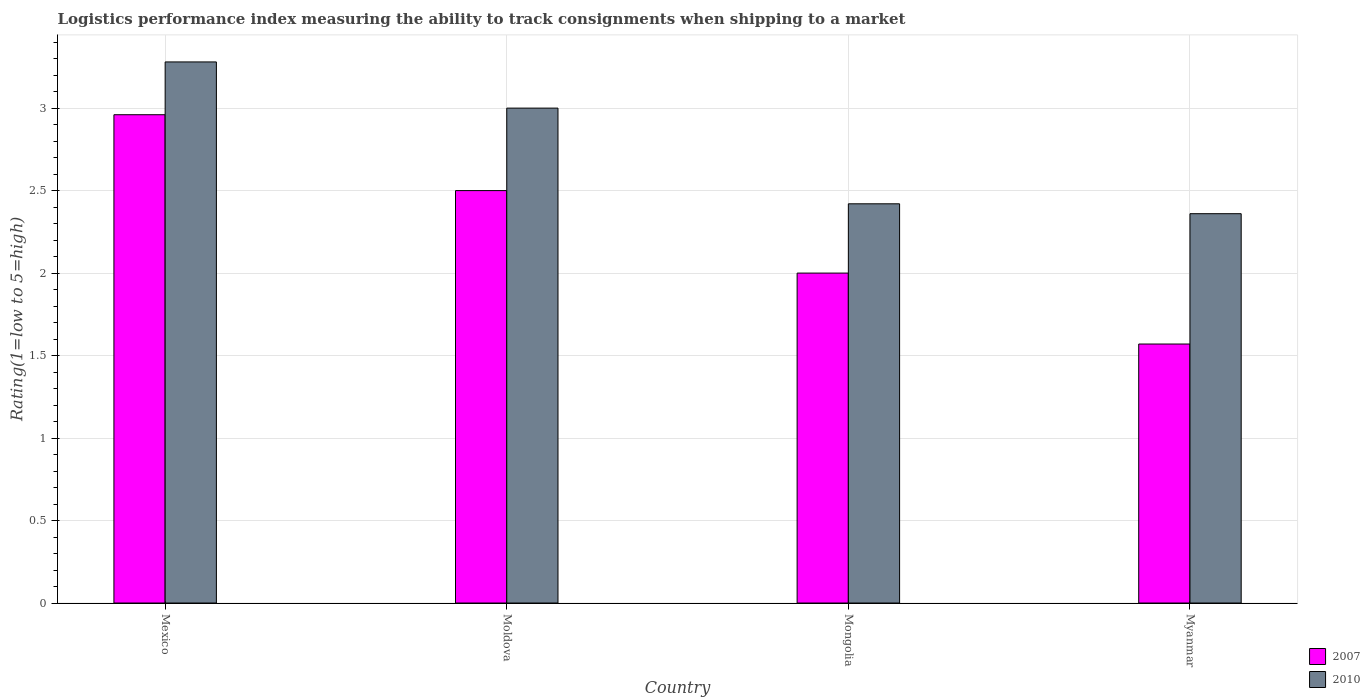How many different coloured bars are there?
Ensure brevity in your answer.  2. Are the number of bars per tick equal to the number of legend labels?
Provide a succinct answer. Yes. What is the label of the 4th group of bars from the left?
Your response must be concise. Myanmar. What is the Logistic performance index in 2007 in Mexico?
Offer a terse response. 2.96. Across all countries, what is the maximum Logistic performance index in 2007?
Make the answer very short. 2.96. Across all countries, what is the minimum Logistic performance index in 2007?
Keep it short and to the point. 1.57. In which country was the Logistic performance index in 2007 minimum?
Your answer should be compact. Myanmar. What is the total Logistic performance index in 2007 in the graph?
Provide a short and direct response. 9.03. What is the difference between the Logistic performance index in 2010 in Mexico and that in Mongolia?
Offer a terse response. 0.86. What is the difference between the Logistic performance index in 2007 in Mongolia and the Logistic performance index in 2010 in Mexico?
Your answer should be very brief. -1.28. What is the average Logistic performance index in 2007 per country?
Provide a succinct answer. 2.26. What is the difference between the Logistic performance index of/in 2010 and Logistic performance index of/in 2007 in Mongolia?
Offer a terse response. 0.42. In how many countries, is the Logistic performance index in 2010 greater than 0.1?
Your response must be concise. 4. What is the ratio of the Logistic performance index in 2010 in Mongolia to that in Myanmar?
Provide a succinct answer. 1.03. What is the difference between the highest and the second highest Logistic performance index in 2010?
Give a very brief answer. 0.58. What is the difference between the highest and the lowest Logistic performance index in 2007?
Offer a terse response. 1.39. What does the 2nd bar from the left in Moldova represents?
Your response must be concise. 2010. What does the 1st bar from the right in Mexico represents?
Offer a terse response. 2010. How many bars are there?
Keep it short and to the point. 8. Are the values on the major ticks of Y-axis written in scientific E-notation?
Provide a succinct answer. No. Does the graph contain any zero values?
Your answer should be compact. No. Does the graph contain grids?
Provide a succinct answer. Yes. How many legend labels are there?
Offer a very short reply. 2. How are the legend labels stacked?
Offer a very short reply. Vertical. What is the title of the graph?
Offer a terse response. Logistics performance index measuring the ability to track consignments when shipping to a market. Does "2015" appear as one of the legend labels in the graph?
Your response must be concise. No. What is the label or title of the Y-axis?
Your answer should be compact. Rating(1=low to 5=high). What is the Rating(1=low to 5=high) of 2007 in Mexico?
Offer a terse response. 2.96. What is the Rating(1=low to 5=high) of 2010 in Mexico?
Keep it short and to the point. 3.28. What is the Rating(1=low to 5=high) in 2007 in Moldova?
Provide a short and direct response. 2.5. What is the Rating(1=low to 5=high) of 2007 in Mongolia?
Make the answer very short. 2. What is the Rating(1=low to 5=high) in 2010 in Mongolia?
Your response must be concise. 2.42. What is the Rating(1=low to 5=high) in 2007 in Myanmar?
Ensure brevity in your answer.  1.57. What is the Rating(1=low to 5=high) of 2010 in Myanmar?
Offer a very short reply. 2.36. Across all countries, what is the maximum Rating(1=low to 5=high) of 2007?
Give a very brief answer. 2.96. Across all countries, what is the maximum Rating(1=low to 5=high) of 2010?
Your response must be concise. 3.28. Across all countries, what is the minimum Rating(1=low to 5=high) in 2007?
Make the answer very short. 1.57. Across all countries, what is the minimum Rating(1=low to 5=high) in 2010?
Ensure brevity in your answer.  2.36. What is the total Rating(1=low to 5=high) of 2007 in the graph?
Offer a terse response. 9.03. What is the total Rating(1=low to 5=high) in 2010 in the graph?
Provide a succinct answer. 11.06. What is the difference between the Rating(1=low to 5=high) of 2007 in Mexico and that in Moldova?
Make the answer very short. 0.46. What is the difference between the Rating(1=low to 5=high) in 2010 in Mexico and that in Moldova?
Offer a terse response. 0.28. What is the difference between the Rating(1=low to 5=high) of 2010 in Mexico and that in Mongolia?
Provide a short and direct response. 0.86. What is the difference between the Rating(1=low to 5=high) of 2007 in Mexico and that in Myanmar?
Ensure brevity in your answer.  1.39. What is the difference between the Rating(1=low to 5=high) in 2010 in Moldova and that in Mongolia?
Make the answer very short. 0.58. What is the difference between the Rating(1=low to 5=high) in 2010 in Moldova and that in Myanmar?
Keep it short and to the point. 0.64. What is the difference between the Rating(1=low to 5=high) in 2007 in Mongolia and that in Myanmar?
Give a very brief answer. 0.43. What is the difference between the Rating(1=low to 5=high) in 2007 in Mexico and the Rating(1=low to 5=high) in 2010 in Moldova?
Keep it short and to the point. -0.04. What is the difference between the Rating(1=low to 5=high) of 2007 in Mexico and the Rating(1=low to 5=high) of 2010 in Mongolia?
Ensure brevity in your answer.  0.54. What is the difference between the Rating(1=low to 5=high) of 2007 in Mexico and the Rating(1=low to 5=high) of 2010 in Myanmar?
Provide a short and direct response. 0.6. What is the difference between the Rating(1=low to 5=high) in 2007 in Moldova and the Rating(1=low to 5=high) in 2010 in Myanmar?
Ensure brevity in your answer.  0.14. What is the difference between the Rating(1=low to 5=high) in 2007 in Mongolia and the Rating(1=low to 5=high) in 2010 in Myanmar?
Your answer should be very brief. -0.36. What is the average Rating(1=low to 5=high) in 2007 per country?
Ensure brevity in your answer.  2.26. What is the average Rating(1=low to 5=high) of 2010 per country?
Give a very brief answer. 2.77. What is the difference between the Rating(1=low to 5=high) of 2007 and Rating(1=low to 5=high) of 2010 in Mexico?
Offer a very short reply. -0.32. What is the difference between the Rating(1=low to 5=high) of 2007 and Rating(1=low to 5=high) of 2010 in Moldova?
Provide a succinct answer. -0.5. What is the difference between the Rating(1=low to 5=high) of 2007 and Rating(1=low to 5=high) of 2010 in Mongolia?
Your response must be concise. -0.42. What is the difference between the Rating(1=low to 5=high) of 2007 and Rating(1=low to 5=high) of 2010 in Myanmar?
Your response must be concise. -0.79. What is the ratio of the Rating(1=low to 5=high) in 2007 in Mexico to that in Moldova?
Give a very brief answer. 1.18. What is the ratio of the Rating(1=low to 5=high) of 2010 in Mexico to that in Moldova?
Give a very brief answer. 1.09. What is the ratio of the Rating(1=low to 5=high) in 2007 in Mexico to that in Mongolia?
Offer a terse response. 1.48. What is the ratio of the Rating(1=low to 5=high) in 2010 in Mexico to that in Mongolia?
Your response must be concise. 1.36. What is the ratio of the Rating(1=low to 5=high) in 2007 in Mexico to that in Myanmar?
Your response must be concise. 1.89. What is the ratio of the Rating(1=low to 5=high) of 2010 in Mexico to that in Myanmar?
Make the answer very short. 1.39. What is the ratio of the Rating(1=low to 5=high) in 2010 in Moldova to that in Mongolia?
Give a very brief answer. 1.24. What is the ratio of the Rating(1=low to 5=high) of 2007 in Moldova to that in Myanmar?
Provide a short and direct response. 1.59. What is the ratio of the Rating(1=low to 5=high) of 2010 in Moldova to that in Myanmar?
Keep it short and to the point. 1.27. What is the ratio of the Rating(1=low to 5=high) in 2007 in Mongolia to that in Myanmar?
Your answer should be very brief. 1.27. What is the ratio of the Rating(1=low to 5=high) in 2010 in Mongolia to that in Myanmar?
Offer a very short reply. 1.03. What is the difference between the highest and the second highest Rating(1=low to 5=high) of 2007?
Ensure brevity in your answer.  0.46. What is the difference between the highest and the second highest Rating(1=low to 5=high) of 2010?
Your answer should be compact. 0.28. What is the difference between the highest and the lowest Rating(1=low to 5=high) of 2007?
Give a very brief answer. 1.39. 